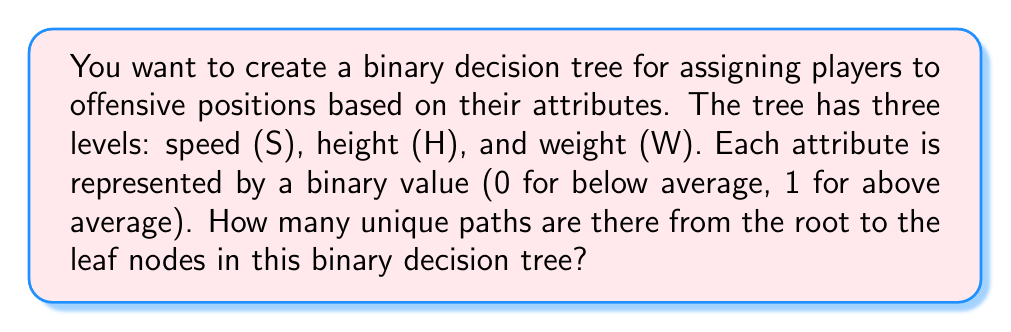Teach me how to tackle this problem. Let's approach this step-by-step:

1) In a binary decision tree, each node splits into two branches.

2) We have three levels in our tree: Speed (S), Height (H), and Weight (W).

3) At each level, we make a binary decision (0 or 1):
   - Level 1 (S): 2 possibilities
   - Level 2 (H): 2 possibilities for each S outcome
   - Level 3 (W): 2 possibilities for each H outcome

4) To calculate the total number of unique paths, we use the multiplication principle of counting:

   $$ \text{Total Paths} = 2 \times 2 \times 2 $$

5) This can be written as:

   $$ \text{Total Paths} = 2^3 $$

6) Calculating:

   $$ 2^3 = 8 $$

Therefore, there are 8 unique paths from the root to the leaf nodes in this binary decision tree.
Answer: 8 